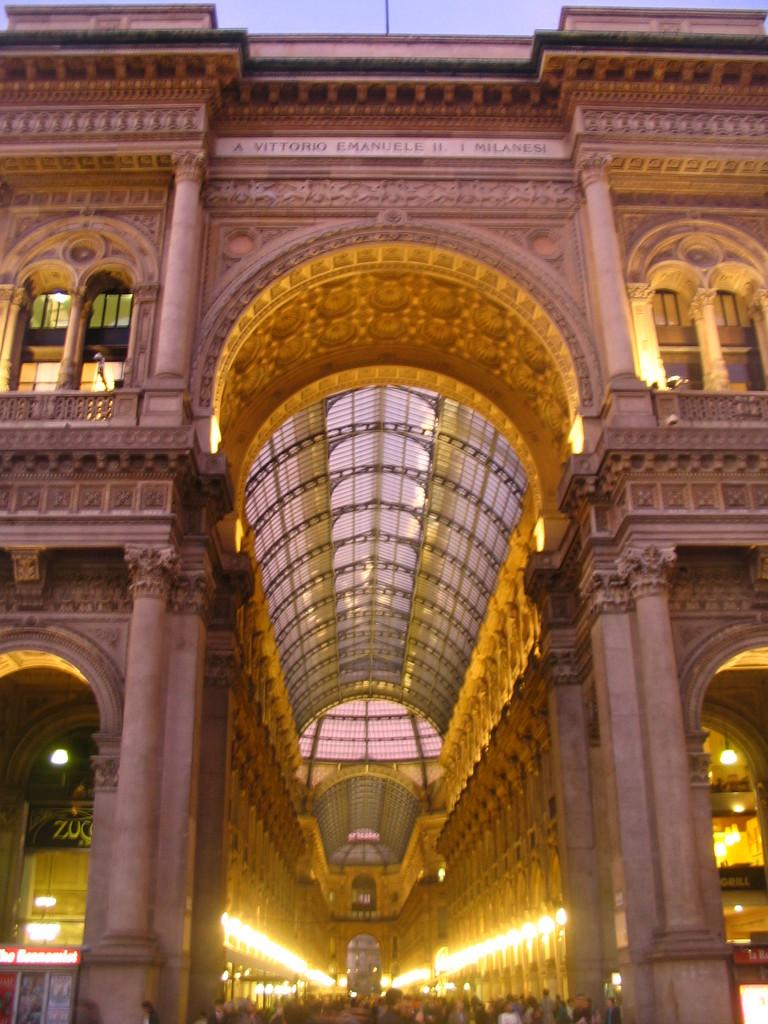What type of structure is present in the image? There is a building in the image. What architectural features can be seen on the building? The building has pillars. Are there any openings in the building? Yes, the building has windows. What color lights are visible in the image? Yellow color lights are visible. What can be seen in the background of the image? There is a sky visible in the background of the image. How many beds are present in the image? There are no beds present in the image; it features a building with pillars, windows, and yellow color lights. 